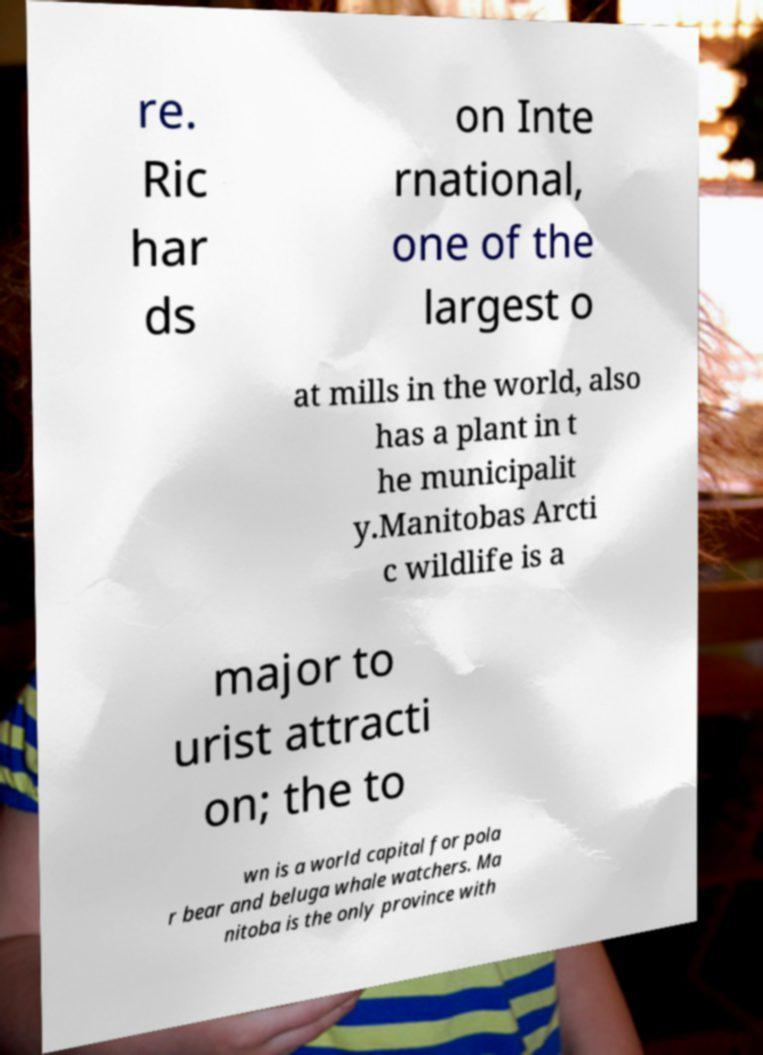For documentation purposes, I need the text within this image transcribed. Could you provide that? re. Ric har ds on Inte rnational, one of the largest o at mills in the world, also has a plant in t he municipalit y.Manitobas Arcti c wildlife is a major to urist attracti on; the to wn is a world capital for pola r bear and beluga whale watchers. Ma nitoba is the only province with 